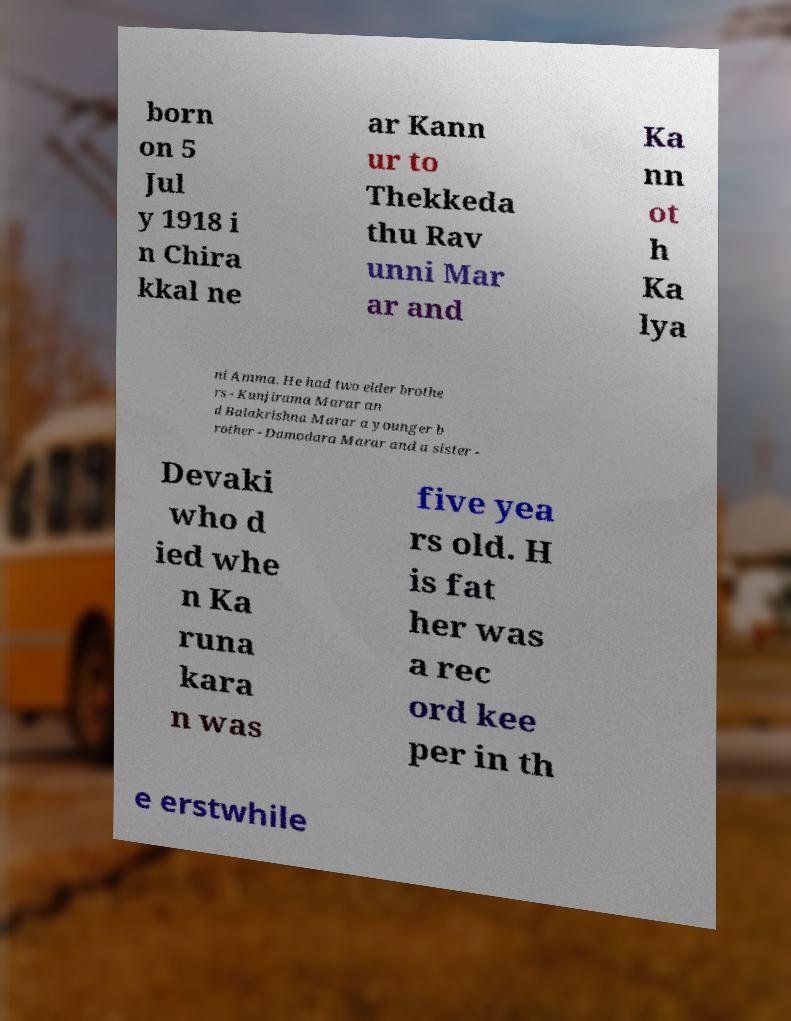Could you extract and type out the text from this image? born on 5 Jul y 1918 i n Chira kkal ne ar Kann ur to Thekkeda thu Rav unni Mar ar and Ka nn ot h Ka lya ni Amma. He had two elder brothe rs - Kunjirama Marar an d Balakrishna Marar a younger b rother - Damodara Marar and a sister - Devaki who d ied whe n Ka runa kara n was five yea rs old. H is fat her was a rec ord kee per in th e erstwhile 